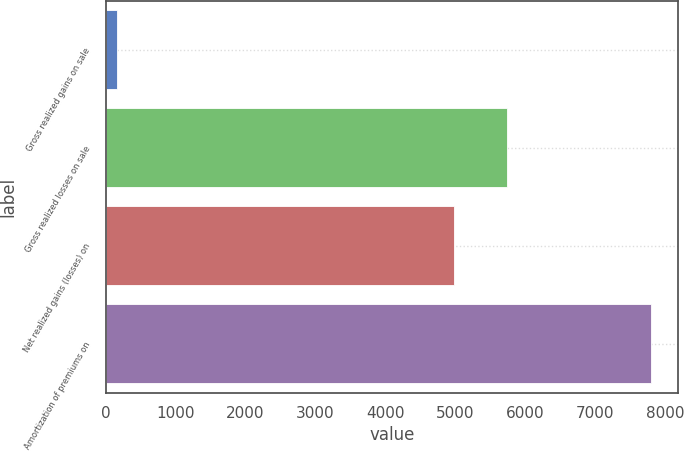<chart> <loc_0><loc_0><loc_500><loc_500><bar_chart><fcel>Gross realized gains on sale<fcel>Gross realized losses on sale<fcel>Net realized gains (losses) on<fcel>Amortization of premiums on<nl><fcel>169<fcel>5743.9<fcel>4981<fcel>7798<nl></chart> 